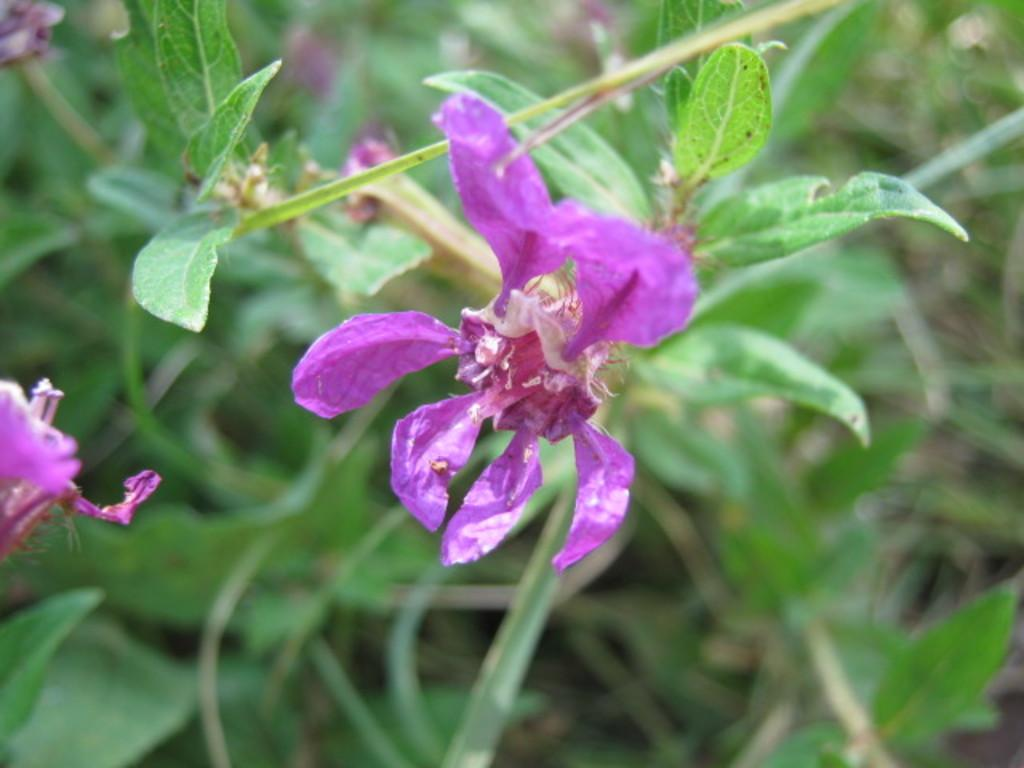What type of flower is in the foreground of the image? There is a lavender color flower in the foreground of the image. What can be seen in the background of the image? There are plants in the background of the image. What year did the flower and plants in the image start their partnership? There is no indication of a partnership between the flower and plants in the image, and the concept of a partnership between plants is not applicable. 